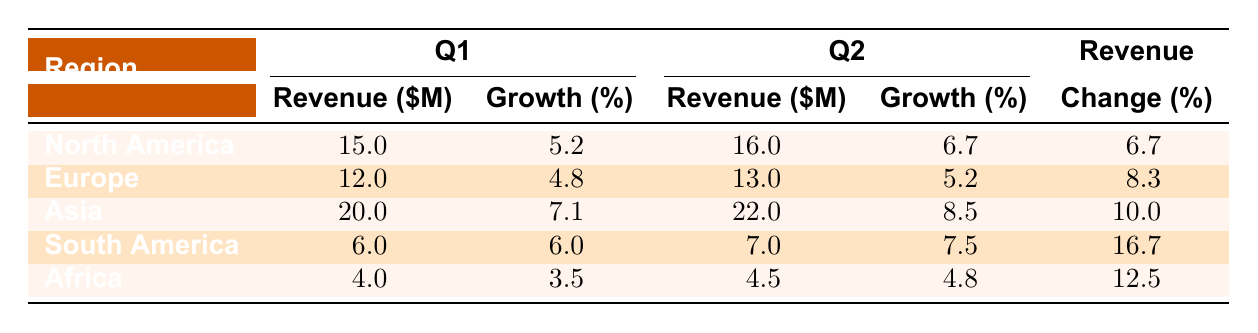What is the revenue for Asia in Q1? The table indicates that the revenue for Asia in Q1 is specifically listed as 20.0 million.
Answer: 20.0 million Which region had the highest revenue in Q2? By comparing the Q2 revenue values in the table, Asia has the highest revenue at 22.0 million, more than any other region.
Answer: Asia What is the growth rate for South America in Q2? The table shows that South America has a growth rate of 7.5% in Q2.
Answer: 7.5% Which region showed the most significant percentage change in revenue between Q1 and Q2? To find the largest percentage change, we compare the changes: North America shows a change of 6.7%, Europe 8.3%, Asia 10.0%, South America 16.7%, and Africa 12.5%. South America has the highest change at 16.7%.
Answer: South America Is the growth rate for Africa in Q1 higher than in Q2? The growth rate for Africa in Q1 is 3.5% while in Q2 it is 4.8%, so it is not true that the Q1 growth rate is higher.
Answer: No What was the total revenue for all regions in Q1? To find the total revenue for Q1, we sum the revenues: 15.0 + 12.0 + 20.0 + 6.0 + 4.0 = 57.0 million.
Answer: 57.0 million Which region has the lowest revenue in Q2? Looking at Q2 revenues, South America has the lowest revenue at 7.0 million compared to others.
Answer: South America If you combine the revenues of North America and Europe in Q1, what is the total? The sum of North America's revenue (15.0 million) and Europe's revenue (12.0 million) in Q1 equals 27.0 million.
Answer: 27.0 million 